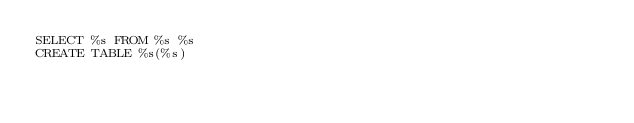Convert code to text. <code><loc_0><loc_0><loc_500><loc_500><_SQL_>SELECT %s FROM %s %s
CREATE TABLE %s(%s)
</code> 